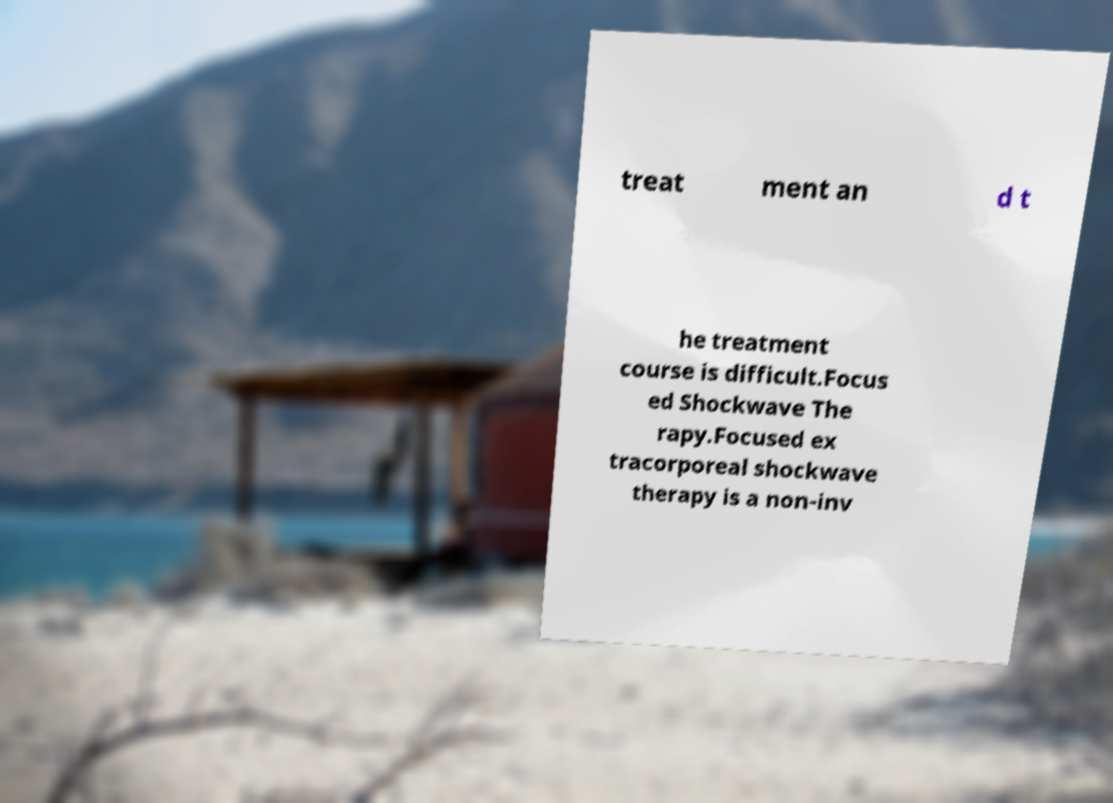Could you assist in decoding the text presented in this image and type it out clearly? treat ment an d t he treatment course is difficult.Focus ed Shockwave The rapy.Focused ex tracorporeal shockwave therapy is a non-inv 